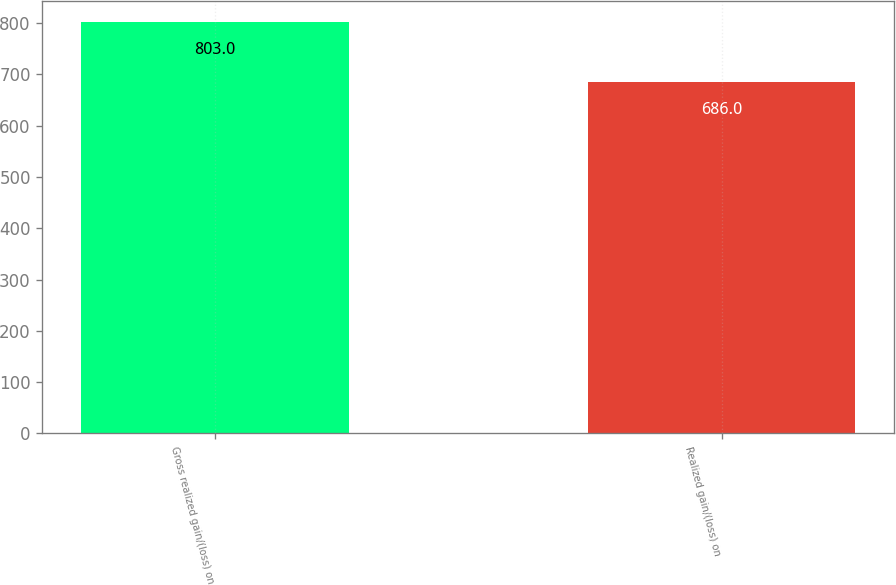Convert chart to OTSL. <chart><loc_0><loc_0><loc_500><loc_500><bar_chart><fcel>Gross realized gain/(loss) on<fcel>Realized gain/(loss) on<nl><fcel>803<fcel>686<nl></chart> 